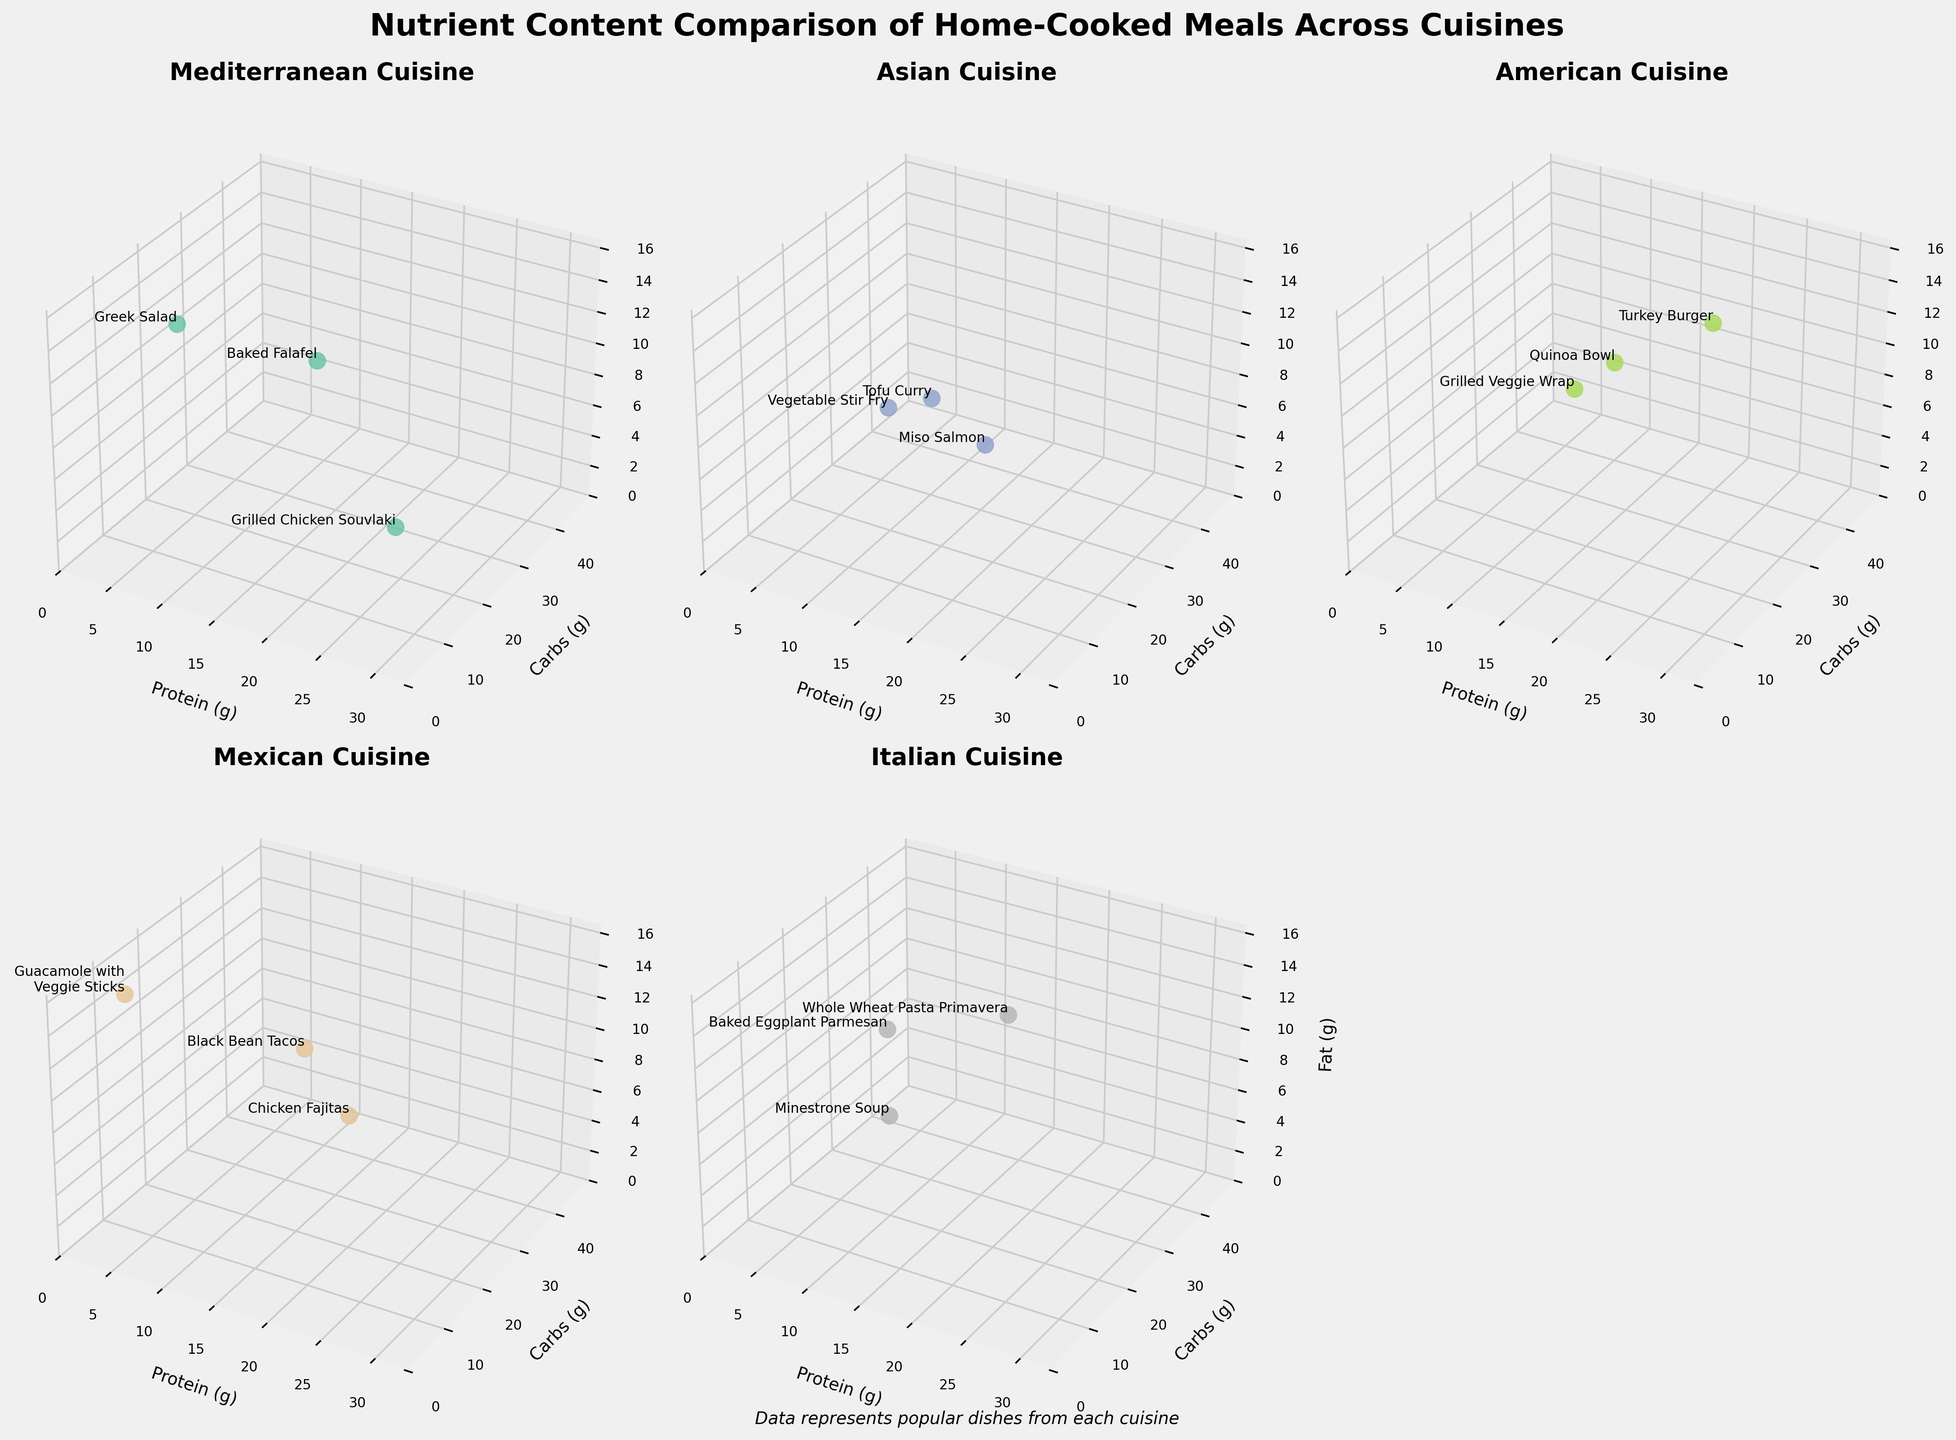What is the title of the figure? The title is displayed at the top of the figure, summarizing the main topic. It reads "Nutrient Content Comparison of Home-Cooked Meals Across Cuisines."
Answer: Nutrient Content Comparison of Home-Cooked Meals Across Cuisines Which cuisine has the dish with the highest protein content? By examining the labels associated with the points in the plots, we find that "Grilled Chicken Souvlaki" in the Mediterranean cuisine subplot has the highest protein content of 30g.
Answer: Mediterranean What are the carbohydrate content ranges for the American meals? In the subplot for American cuisine, the carbohydrate content ranges can be observed on the y-axis values of the data points. They range from 25g to 35g.
Answer: 25g to 35g How does the fat content of "Tofu Curry" compare with "Baked Eggplant Parmesan"? In the Asian subplot, "Tofu Curry" has a fat content of 10g, while in the Italian subplot, "Baked Eggplant Parmesan" has a fat content of 12g. Comparing these values shows that "Baked Eggplant Parmesan" has more fat.
Answer: "Baked Eggplant Parmesan" has more fat Which dish in the Italian subplot has the lowest carbohydrate content? In the Italian subplot, by reviewing the carbohydrate content (y-axis) for each dish, we find that "Minestrone Soup" has the lowest carbohydrate content at 25g.
Answer: Minestrone Soup What is the average protein content of the Asian meals? The protein contents of the Asian meals are 10g (Vegetable Stir Fry), 25g (Miso Salmon), and 15g (Tofu Curry). Adding these values gives 10 + 25 + 15 = 50g, and the average is 50/3 ≈ 16.67g.
Answer: ≈ 16.67g Which meal has the highest fat content in the Mexican cuisine? In the Mexican subplot, by looking at the fat content (z-axis) of each data point, we find that "Guacamole with Veggie Sticks" has the highest fat content at 15g.
Answer: Guacamole with Veggie Sticks Is there any meal with exactly 10g fat content in the Mediterranean cuisine? By examining the Mediterranean cuisine subplot and looking at the fat content (z-axis), we note that "Baked Falafel" has exactly 10g of fat.
Answer: Yes, "Baked Falafel" Compare the dishes "Greek Salad" and "Grilled Veggie Wrap" in terms of protein content and fat content. "Greek Salad" (Mediterranean) has 8g of protein and 15g of fat, while "Grilled Veggie Wrap" (American) has 10g of protein and 7g of fat. Thus, "Grilled Veggie Wrap" has more protein but less fat compared to "Greek Salad."
Answer: "Grilled Veggie Wrap" has more protein but less fat Which were the dishes with data points located in the top right quadrant of the American cuisine 3D plot? In the American subplot, the top right quadrant would correspond to the highest values on the protein (x-axis) and carbohydrate (y-axis) dimensions. The dishes located here are "Turkey Burger" and "Quinoa Bowl."
Answer: "Turkey Burger" and "Quinoa Bowl" 